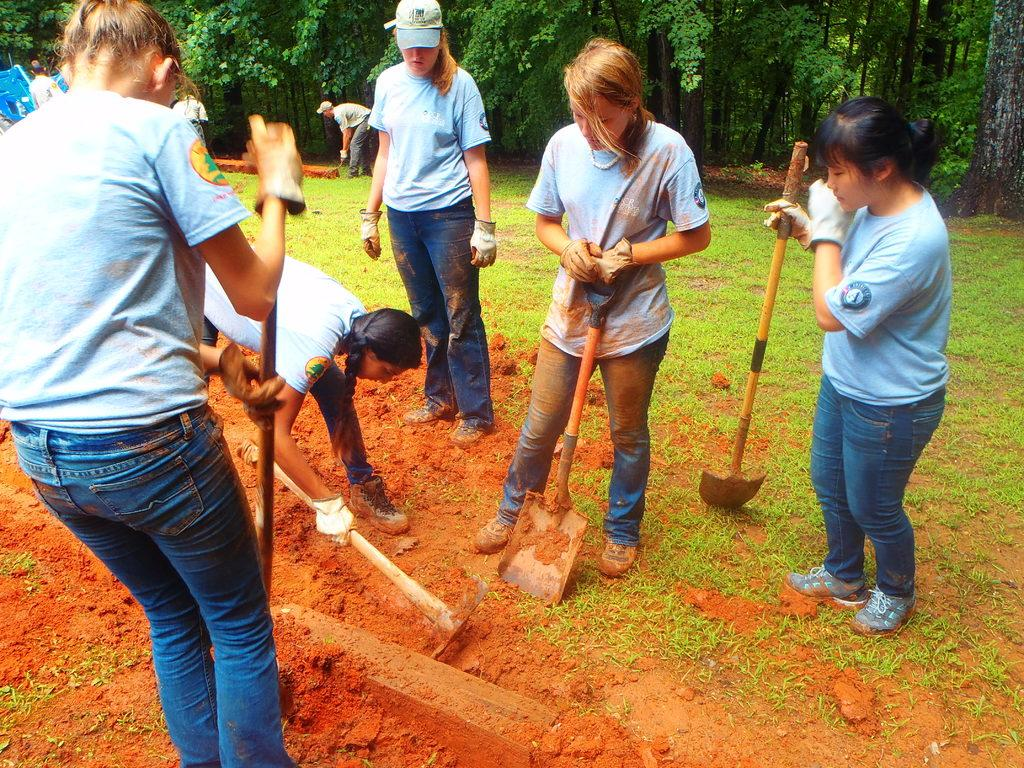What are the people in the image doing? The people in the image are digging the ground. What tools are the people using for digging? The people are holding equipment for digging. Can you describe the background of the image? There are other people and trees visible in the background of the image. What type of cheese can be seen in the image? There is no cheese present in the image. How many people are lifting heavy objects in the image? There is no lifting of heavy objects depicted in the image; the people are digging the ground. 